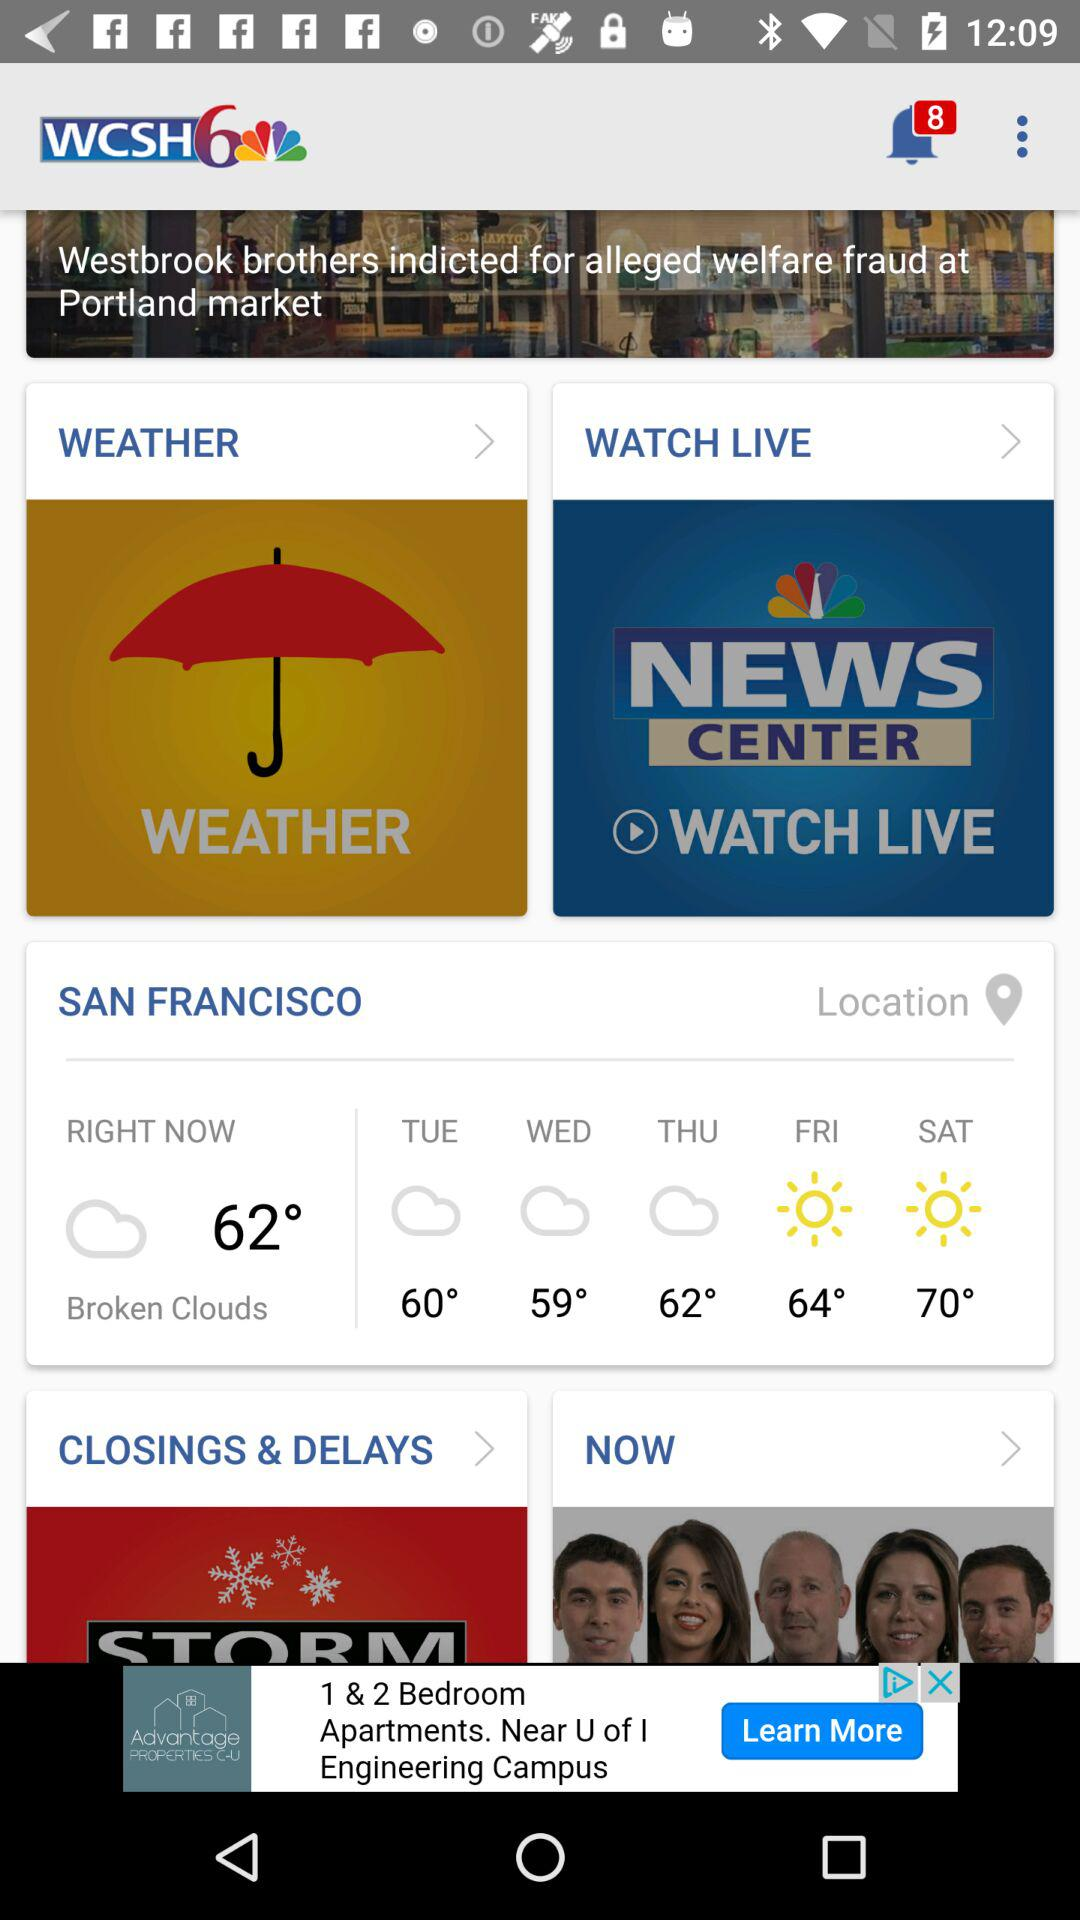How many unread notifications are there? There are 8 unread notifications. 